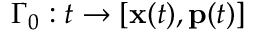Convert formula to latex. <formula><loc_0><loc_0><loc_500><loc_500>\Gamma _ { 0 } \colon t \to [ x ( t ) , p ( t ) ]</formula> 